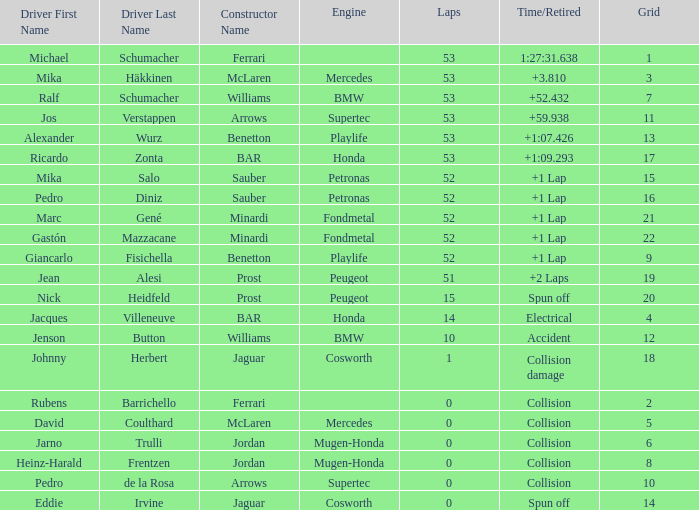What is the name of the driver with a grid less than 14, laps smaller than 53 and a Time/Retired of collision, and a Constructor of ferrari? Rubens Barrichello. 